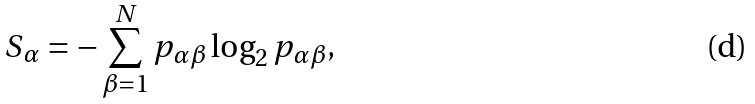<formula> <loc_0><loc_0><loc_500><loc_500>S _ { \alpha } = - \sum _ { \beta = 1 } ^ { N } p _ { \alpha \beta } \log _ { 2 } p _ { \alpha \beta } ,</formula> 